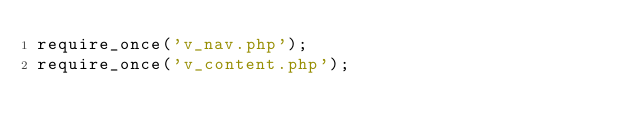Convert code to text. <code><loc_0><loc_0><loc_500><loc_500><_PHP_>require_once('v_nav.php');
require_once('v_content.php');</code> 